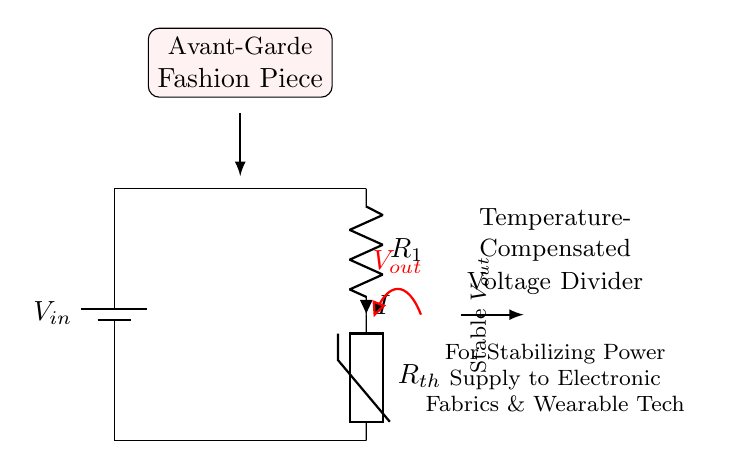What is the input voltage of the circuit? The input voltage is labeled as \( V_{in} \) at the battery terminal on the left side of the circuit diagram.
Answer: \( V_{in} \) What type of resistor is used in the voltage divider? The resistor used in this voltage divider circuit is labeled as \( R_1 \) and it corresponds to a standard resistor. The other component, \( R_{th} \), is a thermistor used for temperature compensation.
Answer: Standard resistor What is the purpose of the thermistor in this circuit? The thermistor, labeled \( R_{th} \), is used for temperature compensation, adjusting the resistance based on temperature changes to stabilize the output voltage.
Answer: Stabilization What is the output voltage indicated in the circuit? The output voltage is labeled as \( V_{out} \) located at the junction where \( R_1 \) and \( R_{th} \) are connected, indicating the voltage drop across them.
Answer: \( V_{out} \) How does the temperature affect the voltage divider's output? As the temperature changes, the resistance of the thermistor \( R_{th} \) changes, which affects the voltage drop over \( R_{th} \), consequently stabilizing \( V_{out} \) against temperature variations.
Answer: Affects stability What is the total current in the circuit denoted as? The total current flowing through the circuit is labeled as \( I \) next to \( R_1 \), representing the current that follows through the voltage divider.
Answer: \( I \) What is the theme of the design emphasized in the circuit diagram? The theme is highlighted in the circuit with notes mentioning "Avant-Garde Fashion Piece", indicating that the design is innovative and tailored for luxury fashion applications.
Answer: Avant-Garde Fashion Piece 